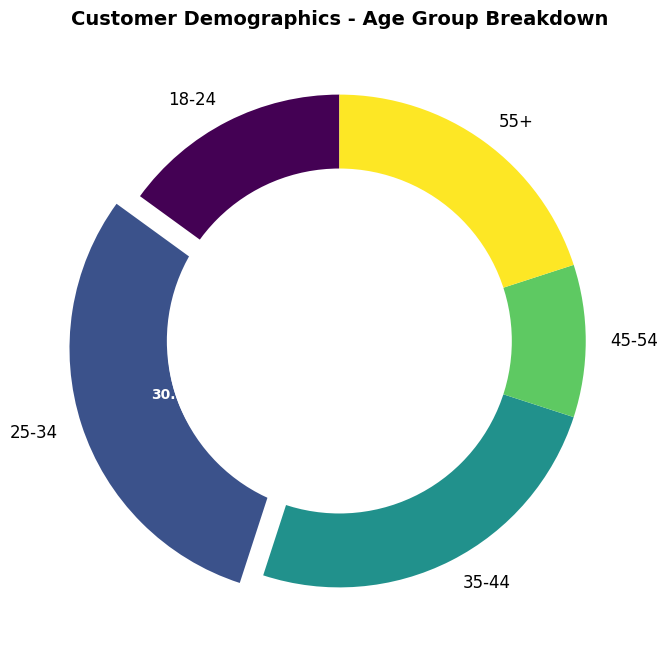what is the largest age group represented? The largest age group is represented by the segment with the highest percentage. In the plot, we see that the 25-34 age group has the largest segment, highlighted by the explosion effect, indicating it represents 30.0% of the total.
Answer: 25-34 Which age groups together represent more than 50% of the customer base? To find the age groups that together represent more than 50% of the customer base, we need to combine the percentages of the largest groups until we exceed 50%. The 25-34 group represents 30.0%, and the 35-44 group represents 25.0%. Together, they sum to 55.0%, which exceeds 50%.
Answer: 25-34 and 35-44 What percentage of the customer base is aged 45 and older? To find the percentage of the customer base that is aged 45 and older, sum the percentages for the 45-54 and 55+ groups. The 45-54 group represents 10.0%, and the 55+ group represents 20.0%. Together, they sum to 30.0%.
Answer: 30.0% How does the percentage of the 18-24 age group compare to that of the 55+ age group? To compare the percentages of the 18-24 and 55+ age groups, we observe that the 18-24 group represents 15.0%, while the 55+ group represents 20.0%. Thus, the 55+ age group has a higher percentage.
Answer: The 55+ percentage is higher Is the percentage of the 35-44 age group greater than half of the 25-34 age group's percentage? The 35-44 age group's percentage is 25.0%, and the 25-34 age group's percentage is 30.0%. Half of 30.0% is 15.0%. Since 25.0% is greater than 15.0%, the 35-44 percentage is greater than half of the 25-34 percentage.
Answer: Yes What is the distribution ratio between the youngest age group (18-24) and the oldest age group (55+)? To compute the distribution ratio between the 18-24 and 55+ age groups, we compare their counts. The 18-24 group has 150 individuals, and the 55+ group has 200 individuals. The ratio is 150:200, which simplifies to 3:4.
Answer: 3:4 How does the sum of customers aged 18-24 and 45-54 compare to the count of customers aged 35-44? The 18-24 group has 150 individuals, and the 45-54 group has 100 individuals. Summing them gives 150 + 100 = 250. The 35-44 group also has 250 individuals. Hence, the sums are equal.
Answer: They are equal Which age group has the lowest percentage representation, and what is it? The lowest percentage representation is seen by the smallest segment in the plot. The 45-54 age group has the smallest segment, representing 10.0% of the total.
Answer: 45-54 age group with 10.0% How many age groups represent less than 20% of the customer base each? Identify the segments with less than 20% representation. The groups 18-24 (15.0%), 45-54 (10.0%), and 55+ (20.0%) are considered. Note that the 55+ group represents exactly 20%, so there are only two groups: 18-24 and 45-54.
Answer: Two age groups What is the average number of customers in each age group? Calculate the average by summing the counts of all age groups and dividing by the number of age groups. The total count is 150 + 300 + 250 + 100 + 200 = 1000. There are 5 age groups. The average is 1000 / 5 = 200.
Answer: 200 